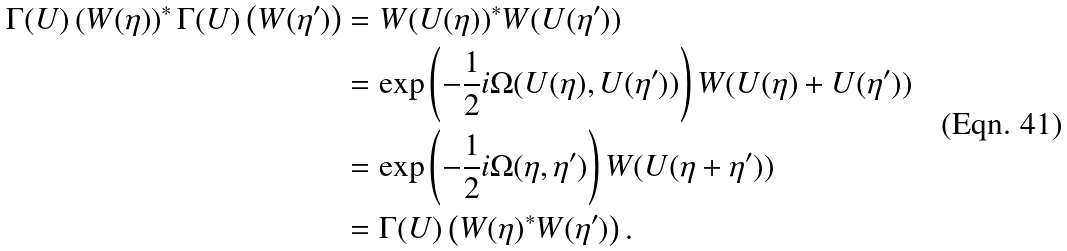Convert formula to latex. <formula><loc_0><loc_0><loc_500><loc_500>\Gamma ( U ) \left ( W ( \eta ) \right ) ^ { * } \Gamma ( U ) \left ( W ( \eta ^ { \prime } ) \right ) & = W ( U ( \eta ) ) ^ { * } W ( U ( \eta ^ { \prime } ) ) \\ & = \exp \left ( - \frac { 1 } { 2 } i \Omega ( U ( \eta ) , U ( \eta ^ { \prime } ) ) \right ) W ( U ( \eta ) + U ( \eta ^ { \prime } ) ) \\ & = \exp \left ( - \frac { 1 } { 2 } i \Omega ( \eta , \eta ^ { \prime } ) \right ) W ( U ( \eta + \eta ^ { \prime } ) ) \\ & = \Gamma ( U ) \left ( W ( \eta ) ^ { * } W ( \eta ^ { \prime } ) \right ) .</formula> 